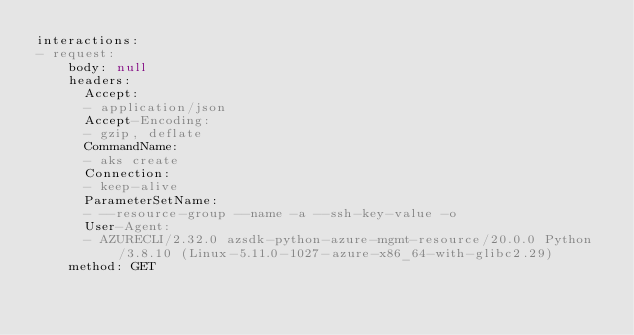Convert code to text. <code><loc_0><loc_0><loc_500><loc_500><_YAML_>interactions:
- request:
    body: null
    headers:
      Accept:
      - application/json
      Accept-Encoding:
      - gzip, deflate
      CommandName:
      - aks create
      Connection:
      - keep-alive
      ParameterSetName:
      - --resource-group --name -a --ssh-key-value -o
      User-Agent:
      - AZURECLI/2.32.0 azsdk-python-azure-mgmt-resource/20.0.0 Python/3.8.10 (Linux-5.11.0-1027-azure-x86_64-with-glibc2.29)
    method: GET</code> 